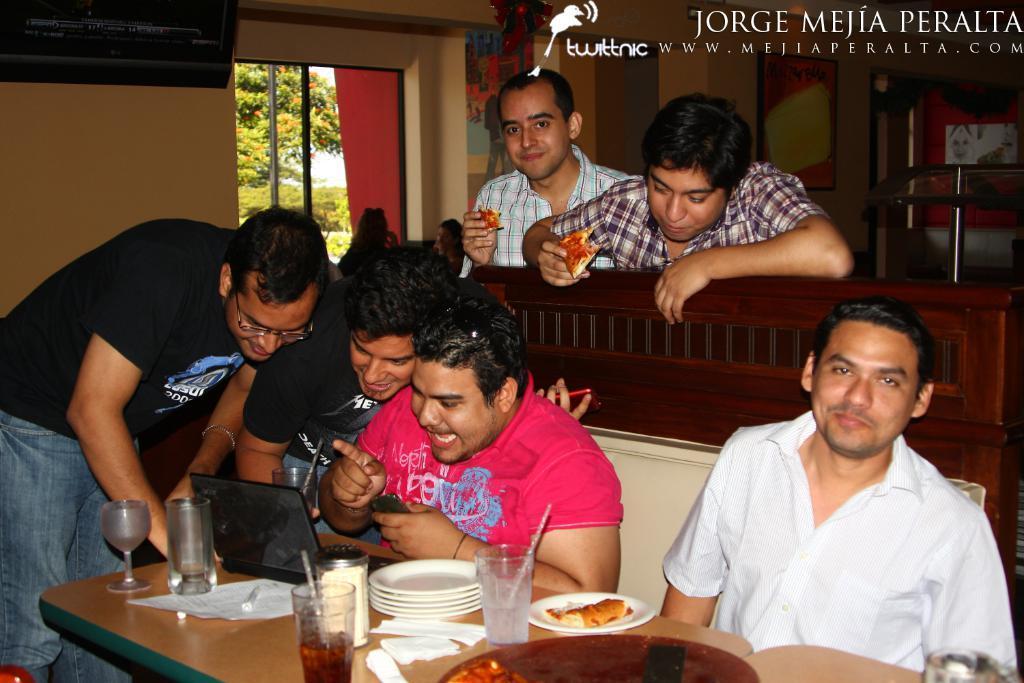Could you give a brief overview of what you see in this image? On the background of the picture we can see a window, trees and a wall. Here we can see two men holding pizza slices in their hands. Here we can see few persons sitting on a sofa in front of table and on the table we can see drinking glasses, tissue papers, plates and a plate of food. We can see these three persons looking into the laptop. 